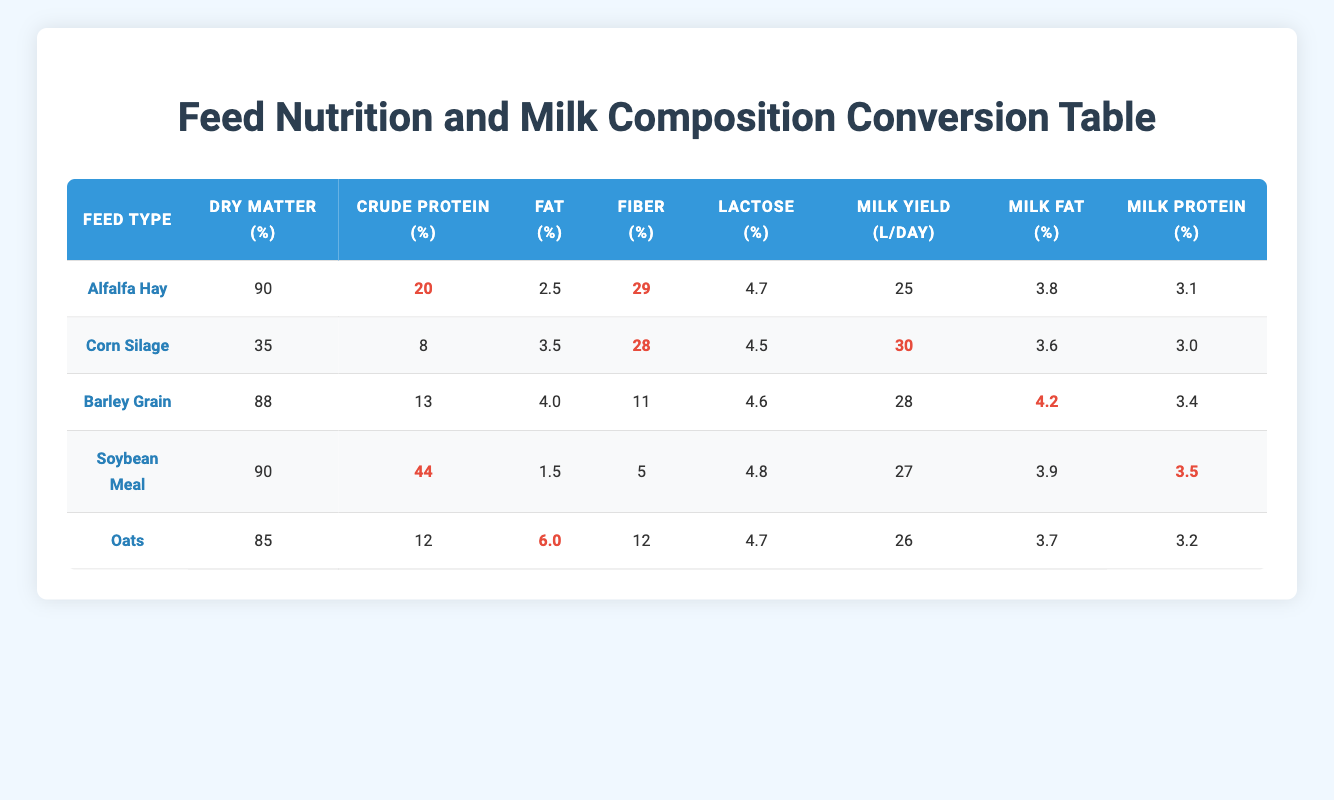What is the crude protein percentage in Soybean Meal? The table lists Soybean Meal under the "Feed Type" column, where the corresponding "Crude Protein" value is shown to be 44%.
Answer: 44 Which feed type has the highest milk yield? By comparing the "Milk Yield" values across all feed types, Corn Silage has the highest milk yield at 30 L/day.
Answer: Corn Silage What is the average fat percentage of all feed types? To find the average fat percentage, sum the fat percentages: (2.5 + 3.5 + 4.0 + 1.5 + 6.0) = 17.5. Then divide by the number of feed types (5): 17.5/5 = 3.5%.
Answer: 3.5 Is the lactose percentage in Alfalfa Hay greater than that in Corn Silage? The lactose percentage for Alfalfa Hay is 4.7%, while for Corn Silage it is 4.5%. Since 4.7 is greater than 4.5, the statement is true.
Answer: Yes If a dairy farmer uses Oats and Soybean Meal, what would be the combined milk protein percentage? According to the table, Oats has a Milk Protein of 3.2% and Soybean Meal has 3.5%. Thus, the combined milk protein is: (3.2% + 3.5%) = 6.7%.
Answer: 6.7 